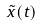<formula> <loc_0><loc_0><loc_500><loc_500>\tilde { x } ( t )</formula> 